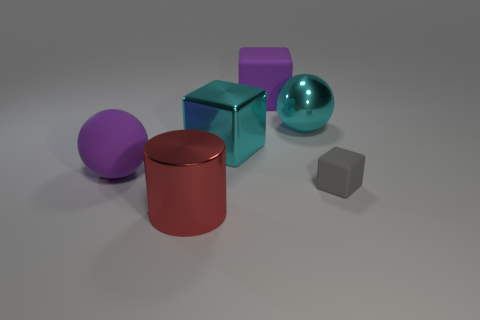What size is the cyan metal object that is the same shape as the gray object?
Offer a terse response. Large. Are there any brown matte cylinders that have the same size as the shiny block?
Provide a short and direct response. No. How many matte things are to the right of the big metallic ball and to the left of the big metallic cube?
Offer a terse response. 0. What number of balls are behind the cyan metal cube?
Make the answer very short. 1. Are there any other yellow matte objects that have the same shape as the small matte object?
Your response must be concise. No. There is a large red object; is it the same shape as the cyan thing that is to the right of the metallic cube?
Make the answer very short. No. What number of cylinders are either red things or large purple matte things?
Give a very brief answer. 1. The large metallic object in front of the large matte sphere has what shape?
Keep it short and to the point. Cylinder. What number of large red objects are made of the same material as the small gray thing?
Offer a terse response. 0. Are there fewer big shiny objects that are behind the cyan metallic block than spheres?
Your answer should be compact. Yes. 